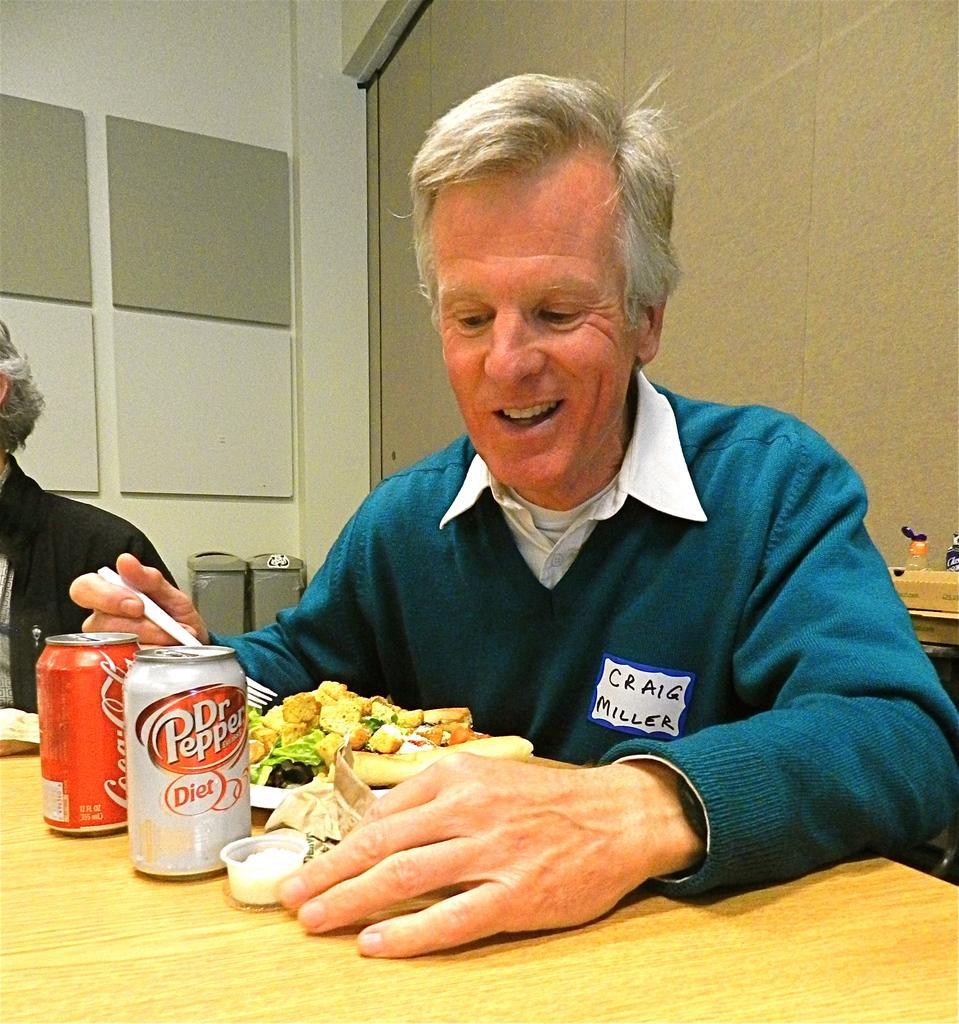In one or two sentences, can you explain what this image depicts? In this picture we can see some food in a plate. There are bottles and cup on the table. We can see a man holding a fork and smiling. There is another person on the left side. We can see a few bottles and other objects on the right side. 